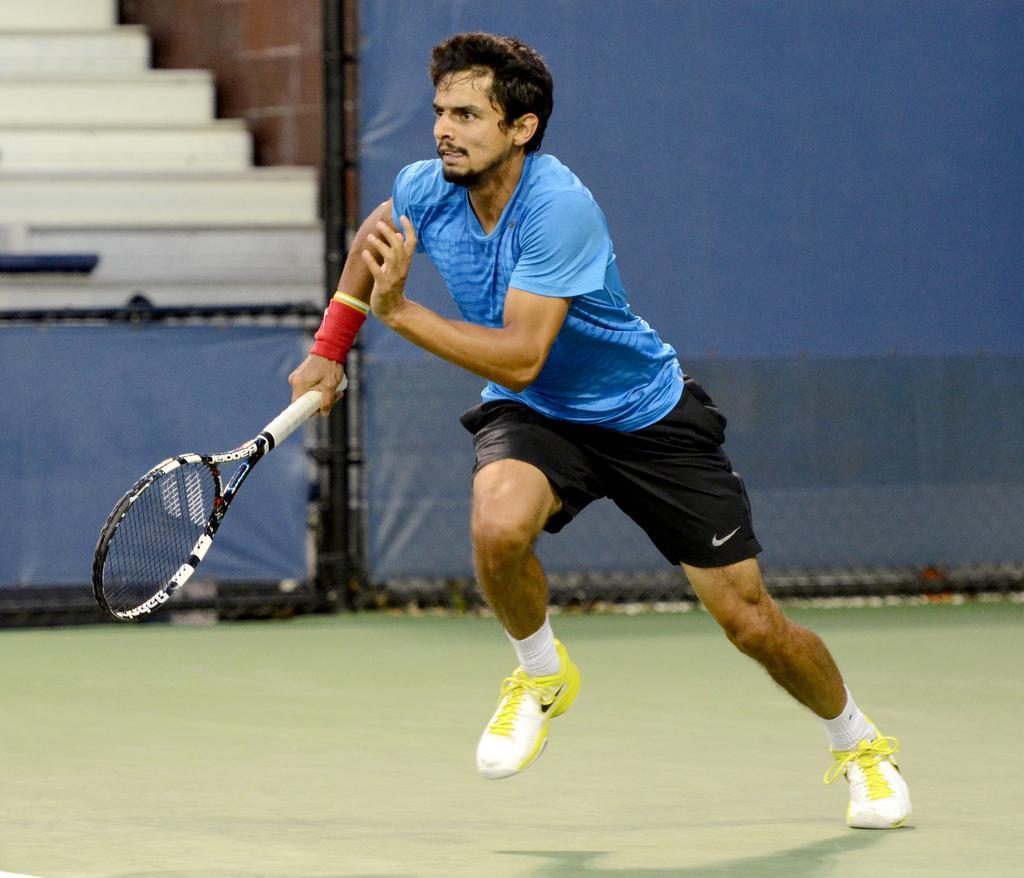Describe this image in one or two sentences. A person is running holding tennis racket in his hand. 